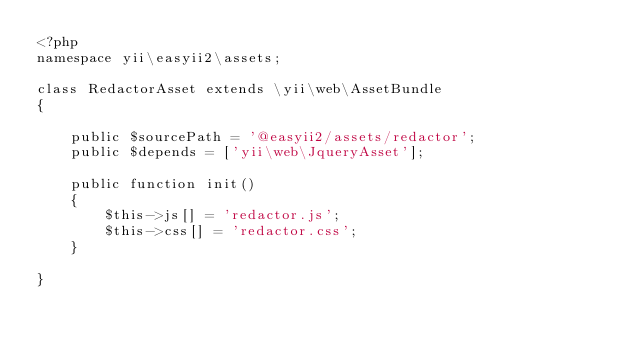<code> <loc_0><loc_0><loc_500><loc_500><_PHP_><?php
namespace yii\easyii2\assets;

class RedactorAsset extends \yii\web\AssetBundle
{

    public $sourcePath = '@easyii2/assets/redactor';
    public $depends = ['yii\web\JqueryAsset'];

    public function init()
    {
        $this->js[] = 'redactor.js';
        $this->css[] = 'redactor.css';
    }

}</code> 